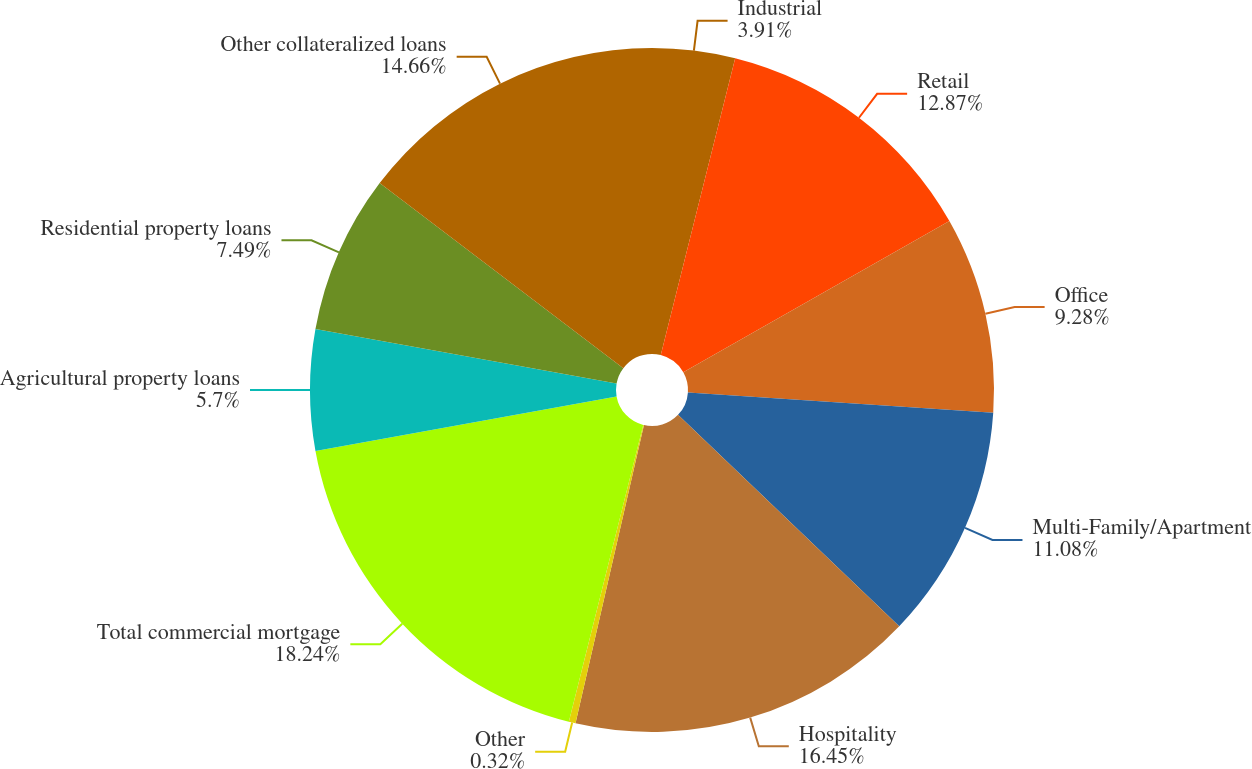Convert chart. <chart><loc_0><loc_0><loc_500><loc_500><pie_chart><fcel>Industrial<fcel>Retail<fcel>Office<fcel>Multi-Family/Apartment<fcel>Hospitality<fcel>Other<fcel>Total commercial mortgage<fcel>Agricultural property loans<fcel>Residential property loans<fcel>Other collateralized loans<nl><fcel>3.91%<fcel>12.87%<fcel>9.28%<fcel>11.08%<fcel>16.45%<fcel>0.32%<fcel>18.24%<fcel>5.7%<fcel>7.49%<fcel>14.66%<nl></chart> 